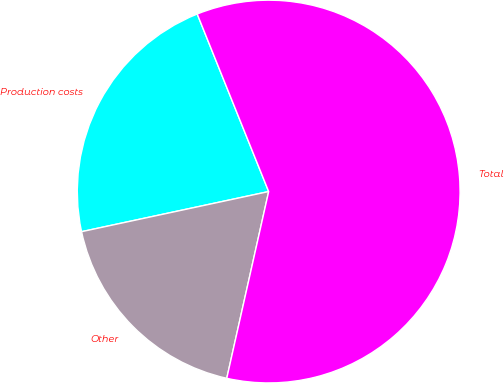Convert chart to OTSL. <chart><loc_0><loc_0><loc_500><loc_500><pie_chart><fcel>Production costs<fcel>Other<fcel>Total<nl><fcel>22.27%<fcel>18.12%<fcel>59.6%<nl></chart> 